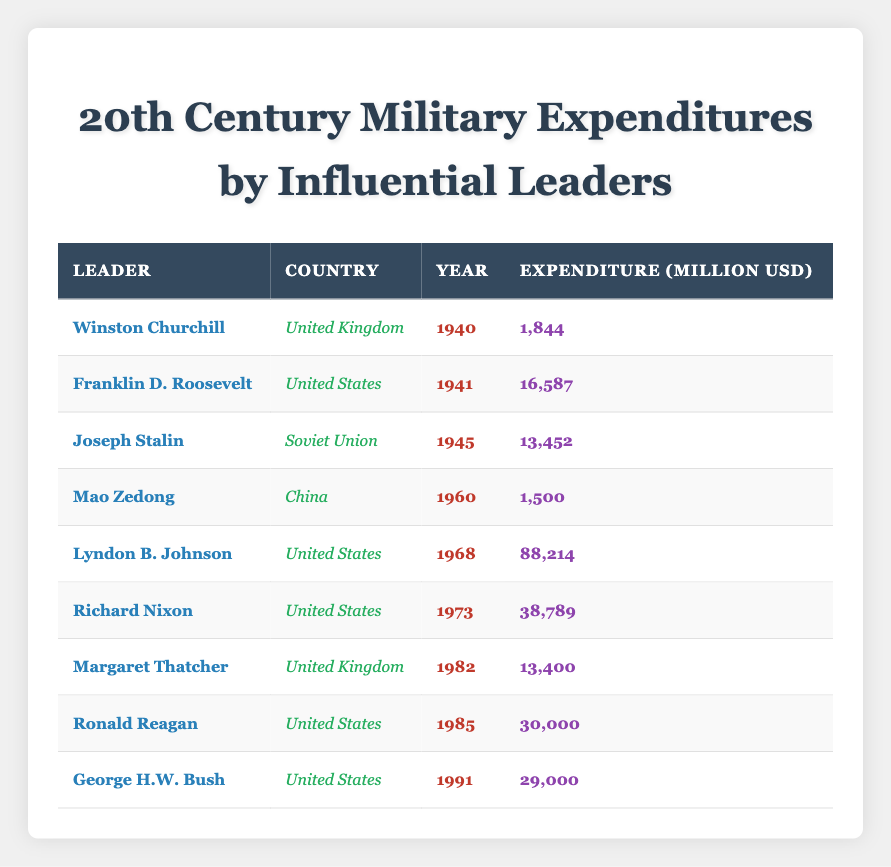What is the highest military expenditure listed in the table? To find the highest military expenditure, I will review all the expenditure values. The expenditures are 1844, 16587, 13452, 1500, 88214, 38789, 13400, 30000, and 29000. Among these, 88214 is the largest.
Answer: 88214 Which leader had the lowest military expenditure? I will compare the expenditures of each leader. Looking through the values, Mao Zedong's expenditure of 1500 million USD is the smallest compared to others.
Answer: Mao Zedong How much did the United States spend on military expenditures in total from 1941 to 1991? The expenditures for the United States are 16587 (1941), 88214 (1968), 38789 (1973), 30000 (1985), and 29000 (1991). Adding these together: 16587 + 88214 + 38789 + 30000 + 29000 = 202590 million USD.
Answer: 202590 Did any United Kingdom leader exceed a military expenditure of 10000 million USD? The expenditures for British leaders are 1844 (Churchill) and 13400 (Thatcher). Comparing these, only Thatcher's expenditure exceeds 10000 million USD, so the answer is yes.
Answer: Yes What is the average military expenditure for leaders from the United States? The leaders from the United States and their expenditures are Franklin D. Roosevelt (16587), Lyndon B. Johnson (88214), Richard Nixon (38789), Ronald Reagan (30000), and George H.W. Bush (29000). Summing these gives: 16587 + 88214 + 38789 + 30000 + 29000 = 202590. There are 5 data points, so the average is 202590 / 5 = 40518.
Answer: 40518 Which year saw the highest military expenditure from the United States? Among the United States leaders, the expenditures and their respective years are: 16587 (1941), 88214 (1968), 38789 (1973), 30000 (1985), and 29000 (1991). The maximum expenditure is 88214 in 1968.
Answer: 1968 How much more did the United States spend on military expenditures in 1968 compared to 1941? The expenditure for the United States in 1968 is 88214 million USD, and in 1941, it is 16587 million USD. The difference can be found by subtracting: 88214 - 16587 = 71627 million USD.
Answer: 71627 Is it true that Joseph Stalin had a higher military expenditure than Margaret Thatcher? Reviewing the expenditures, Joseph Stalin spent 13452 million USD while Margaret Thatcher spent 13400 million USD. Since 13452 is greater than 13400, the statement is true.
Answer: True 